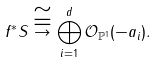<formula> <loc_0><loc_0><loc_500><loc_500>f ^ { * } S \stackrel { \cong } { \rightarrow } \bigoplus _ { i = 1 } ^ { d } \mathcal { O } _ { \mathbb { P } ^ { 1 } } ( - a _ { i } ) .</formula> 